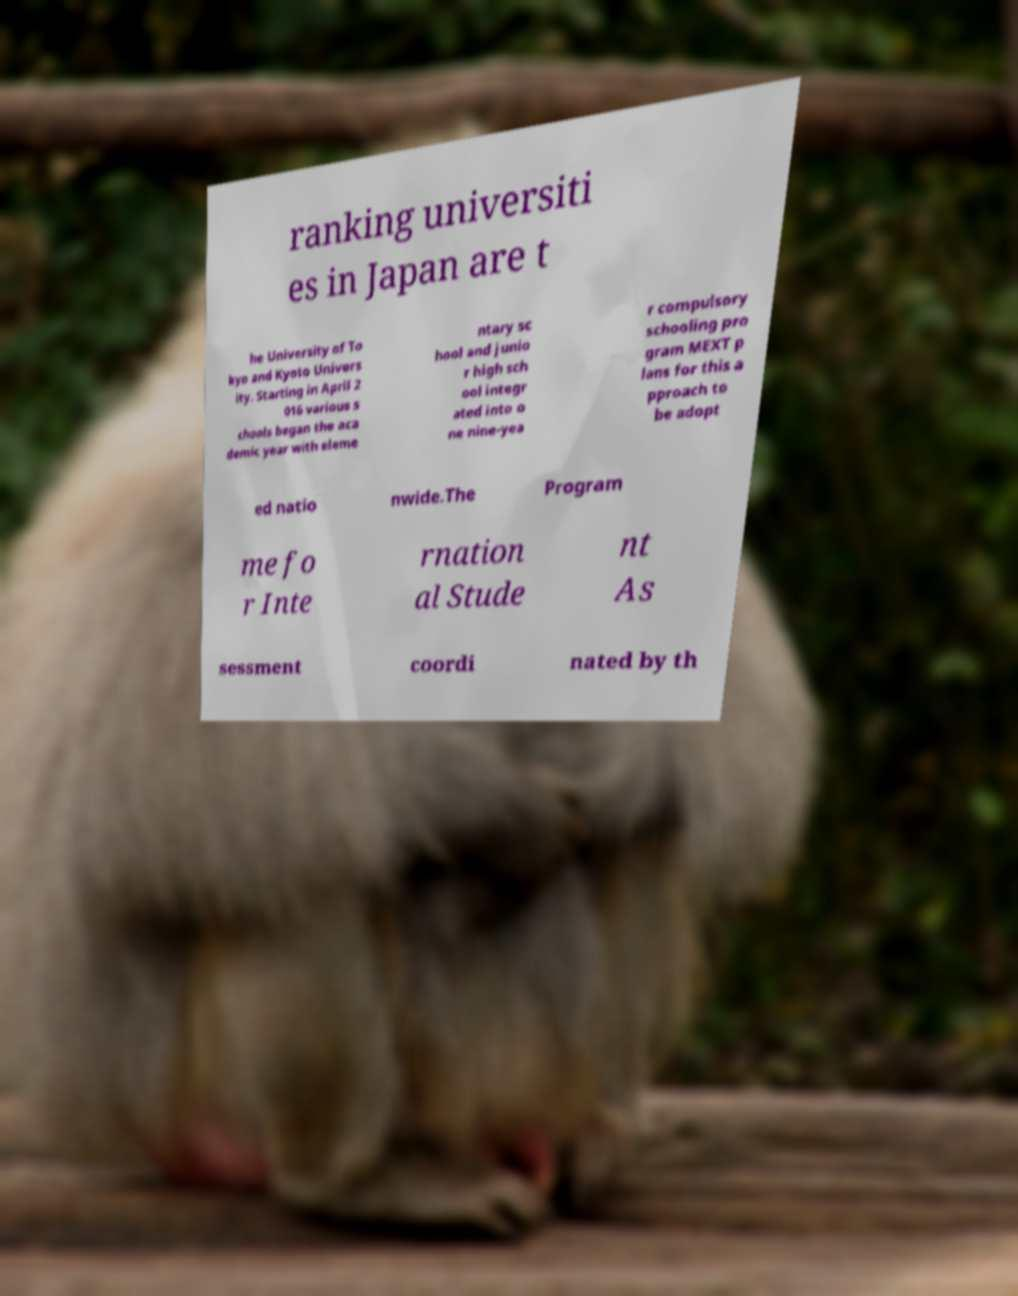What messages or text are displayed in this image? I need them in a readable, typed format. ranking universiti es in Japan are t he University of To kyo and Kyoto Univers ity. Starting in April 2 016 various s chools began the aca demic year with eleme ntary sc hool and junio r high sch ool integr ated into o ne nine-yea r compulsory schooling pro gram MEXT p lans for this a pproach to be adopt ed natio nwide.The Program me fo r Inte rnation al Stude nt As sessment coordi nated by th 